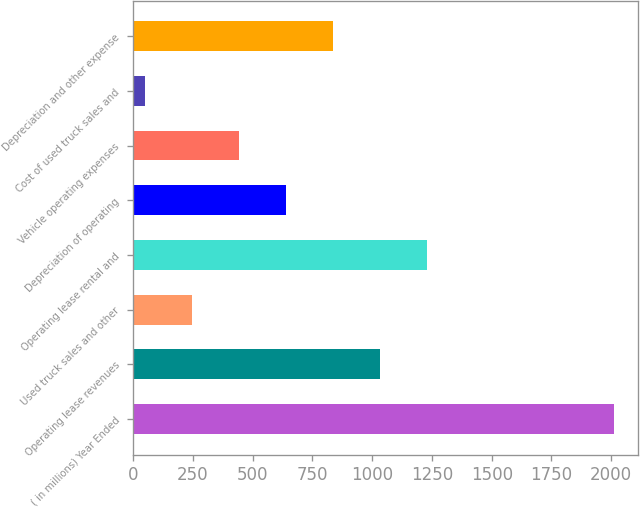Convert chart to OTSL. <chart><loc_0><loc_0><loc_500><loc_500><bar_chart><fcel>( in millions) Year Ended<fcel>Operating lease revenues<fcel>Used truck sales and other<fcel>Operating lease rental and<fcel>Depreciation of operating<fcel>Vehicle operating expenses<fcel>Cost of used truck sales and<fcel>Depreciation and other expense<nl><fcel>2012<fcel>1031.25<fcel>246.65<fcel>1227.4<fcel>638.95<fcel>442.8<fcel>50.5<fcel>835.1<nl></chart> 